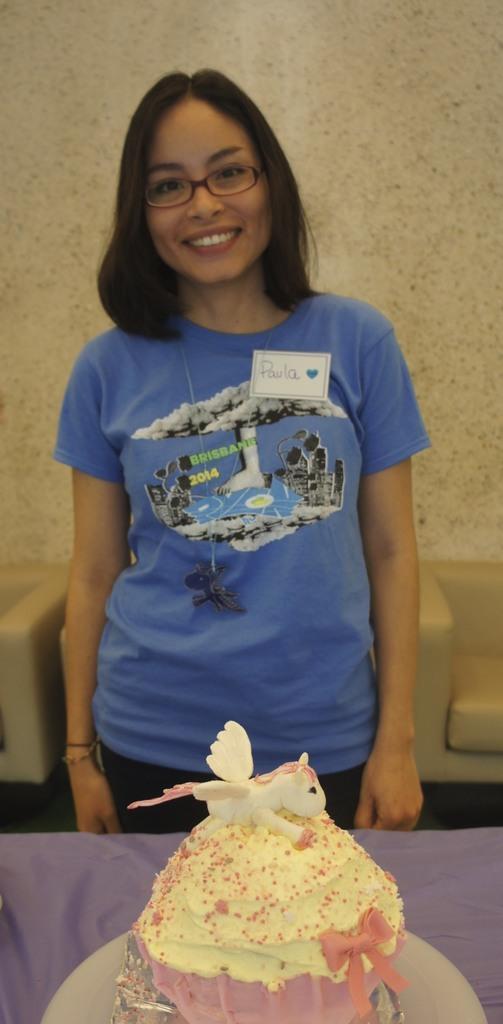Can you describe this image briefly? In this picture there is a girl in the center of the image and there is a cake in front of her and there is sofa in the background area of the image. 